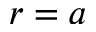<formula> <loc_0><loc_0><loc_500><loc_500>r = a</formula> 